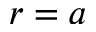<formula> <loc_0><loc_0><loc_500><loc_500>r = a</formula> 